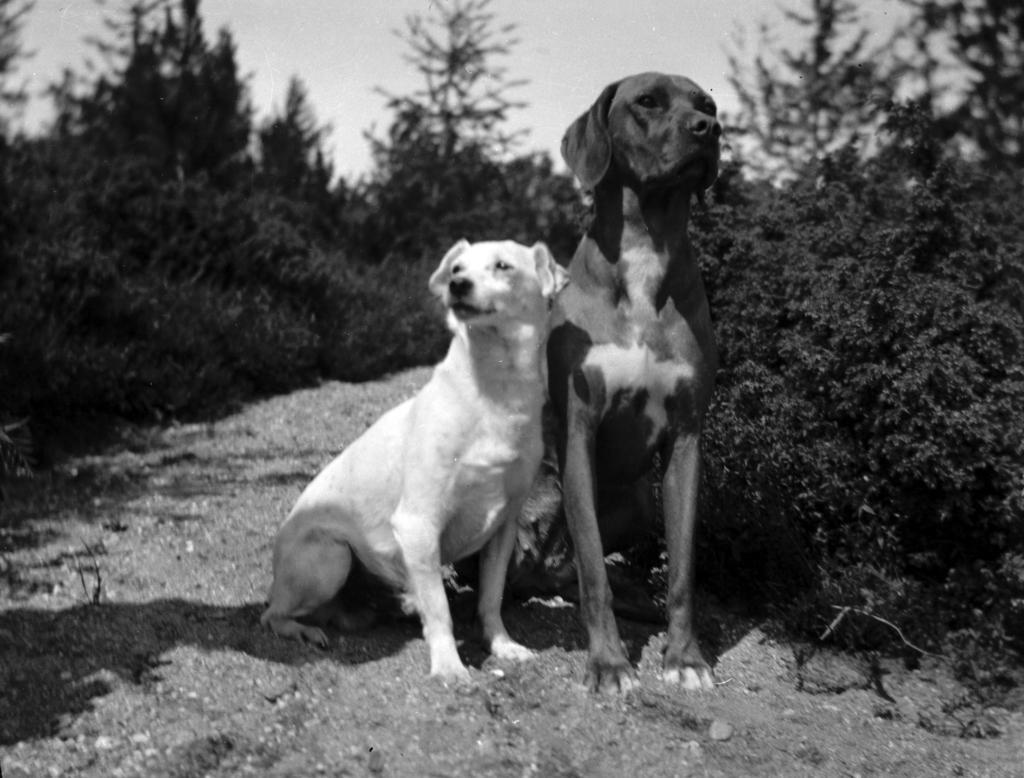In one or two sentences, can you explain what this image depicts? This is a black and white image. In this image we can see two dogs on the ground. We can also see a group of plants and the sky. 